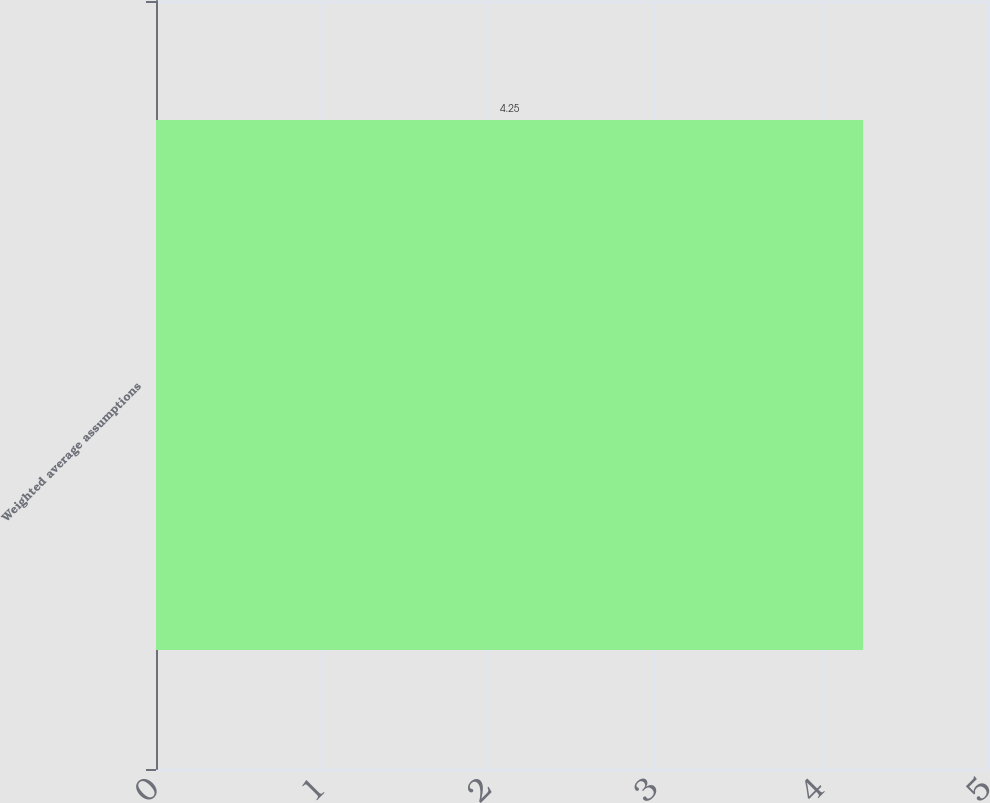Convert chart. <chart><loc_0><loc_0><loc_500><loc_500><bar_chart><fcel>Weighted average assumptions<nl><fcel>4.25<nl></chart> 